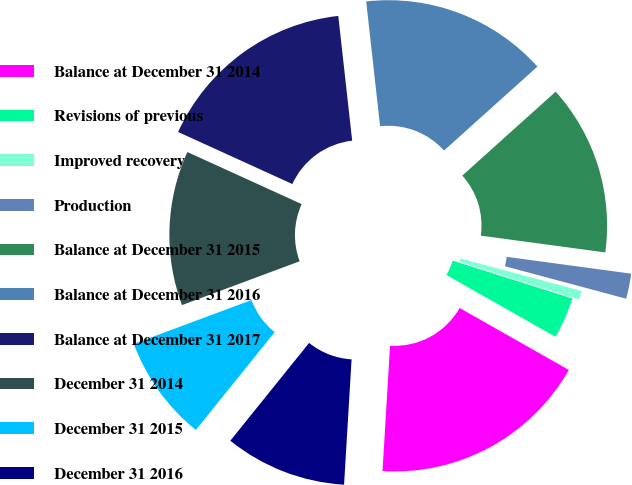Convert chart to OTSL. <chart><loc_0><loc_0><loc_500><loc_500><pie_chart><fcel>Balance at December 31 2014<fcel>Revisions of previous<fcel>Improved recovery<fcel>Production<fcel>Balance at December 31 2015<fcel>Balance at December 31 2016<fcel>Balance at December 31 2017<fcel>December 31 2014<fcel>December 31 2015<fcel>December 31 2016<nl><fcel>17.74%<fcel>3.34%<fcel>0.71%<fcel>2.03%<fcel>13.79%<fcel>15.11%<fcel>16.43%<fcel>12.48%<fcel>8.53%<fcel>9.84%<nl></chart> 